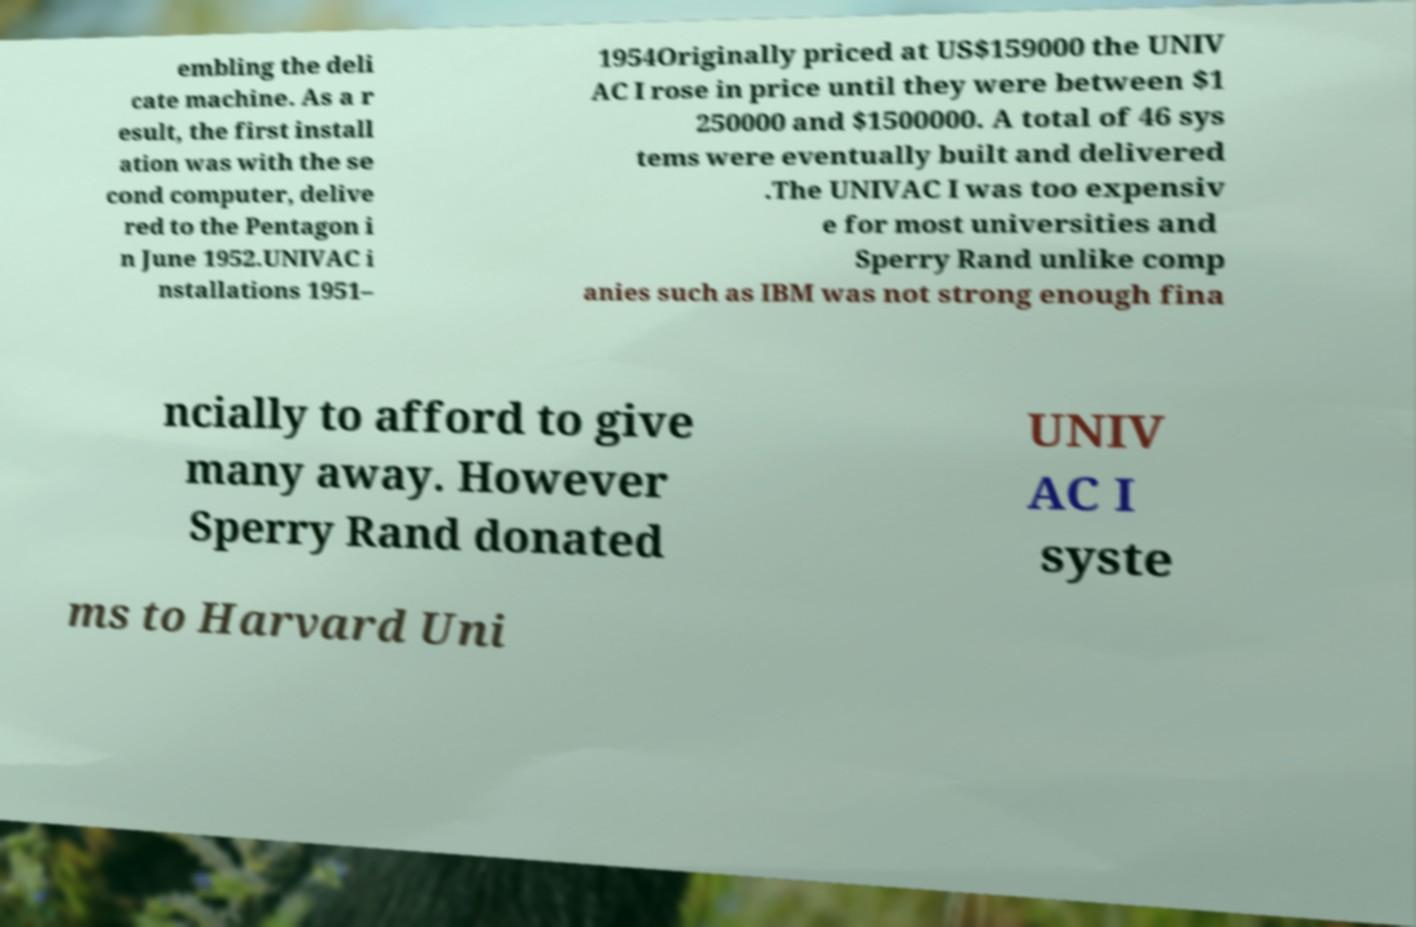I need the written content from this picture converted into text. Can you do that? embling the deli cate machine. As a r esult, the first install ation was with the se cond computer, delive red to the Pentagon i n June 1952.UNIVAC i nstallations 1951– 1954Originally priced at US$159000 the UNIV AC I rose in price until they were between $1 250000 and $1500000. A total of 46 sys tems were eventually built and delivered .The UNIVAC I was too expensiv e for most universities and Sperry Rand unlike comp anies such as IBM was not strong enough fina ncially to afford to give many away. However Sperry Rand donated UNIV AC I syste ms to Harvard Uni 